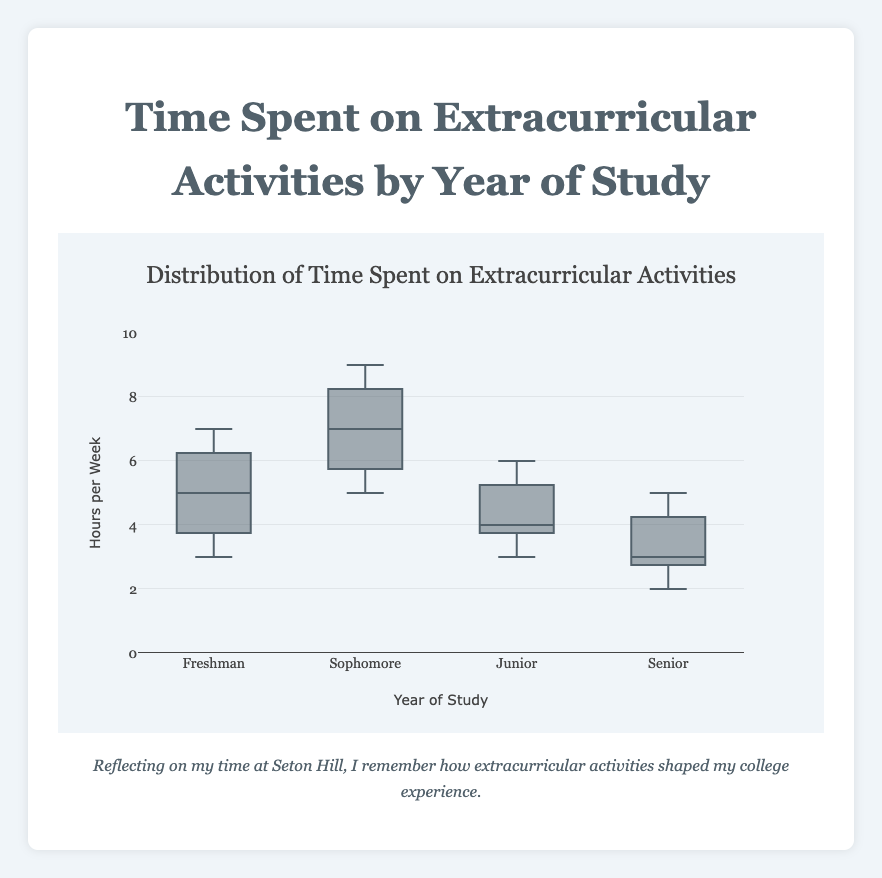What is the title of the plot? The title is usually displayed at the top of the figure. From the provided data and code, the title is explicitly set.
Answer: Time Spent on Extracurricular Activities by Year of Study What is the range of the y-axis? The range of the y-axis is defined in the layout of the plot, which is set to a specific range in the y-axis settings in the code.
Answer: 0 to 10 What year has the highest median time spent on extracurricular activities? To find the year with the highest median, look at the line inside each box, which represents the median. Comparing all the boxes, Sophomore has the highest median.
Answer: Sophomore Which year has the smallest interquartile range (IQR) for time spent on extracurricular activities? The IQR is the range between the first quartile (bottom edge of the box) and the third quartile (top edge of the box). By visually inspecting the boxes, the year with the smallest range is Senior.
Answer: Senior How many years of study are represented in the plot? Each box represents a different year of study. Count the number of distinct boxes to get the answer.
Answer: 4 Which year has the most variability in time spent on extracurricular activities? Variability can be interpreted as the height of the box, which represents the IQR. The taller the box, the higher the variability. Sophomore's box appears to have the most height.
Answer: Sophomore What are the minimum and maximum values of time spent by Juniors? The minimum and maximum values can be inferred from the whiskers of the box plot for Juniors. The bottom whisker goes down to the minimum value and the top whisker extends to the maximum value.
Answer: Minimum: 3, Maximum: 6 Compare the median time spent on extracurricular activities for Freshmen and Seniors. Locate the median line inside each box for Freshmen and Seniors. Compare these two median lines to see which is higher and the difference between them. Freshmen have a higher median than Seniors.
Answer: Freshmen have a higher median What is the most common value of time spent on extracurricular activities for Freshmen? In a box plot, the most common value corresponds to the median. For Freshmen, the median is indicated by the line inside their box.
Answer: 5 Which year of study has the lowest median time spent on extracurricular activities? To determine this, compare the median lines inside each box. The lowest median can be found for Seniors.
Answer: Senior 